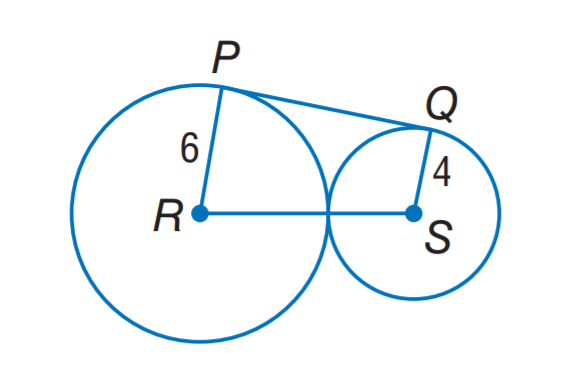Question: P Q is tangent to circles R and S. Find P Q.
Choices:
A. 4 \sqrt 2
B. 6 \sqrt 2
C. 4 \sqrt 6
D. 6 \sqrt 6
Answer with the letter. Answer: C 